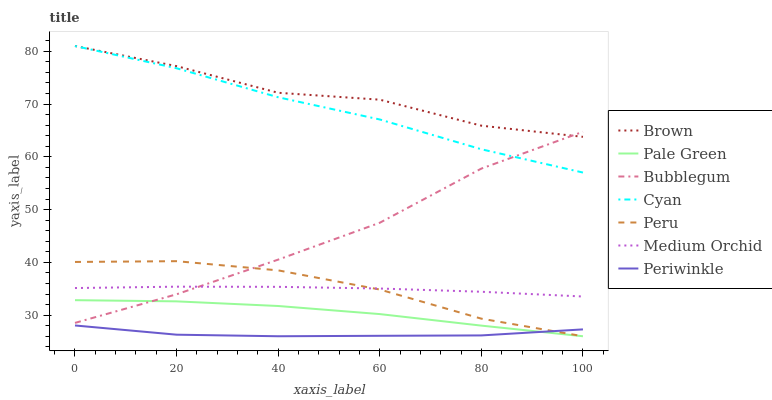Does Periwinkle have the minimum area under the curve?
Answer yes or no. Yes. Does Brown have the maximum area under the curve?
Answer yes or no. Yes. Does Medium Orchid have the minimum area under the curve?
Answer yes or no. No. Does Medium Orchid have the maximum area under the curve?
Answer yes or no. No. Is Medium Orchid the smoothest?
Answer yes or no. Yes. Is Brown the roughest?
Answer yes or no. Yes. Is Bubblegum the smoothest?
Answer yes or no. No. Is Bubblegum the roughest?
Answer yes or no. No. Does Pale Green have the lowest value?
Answer yes or no. Yes. Does Medium Orchid have the lowest value?
Answer yes or no. No. Does Cyan have the highest value?
Answer yes or no. Yes. Does Medium Orchid have the highest value?
Answer yes or no. No. Is Periwinkle less than Medium Orchid?
Answer yes or no. Yes. Is Brown greater than Peru?
Answer yes or no. Yes. Does Brown intersect Bubblegum?
Answer yes or no. Yes. Is Brown less than Bubblegum?
Answer yes or no. No. Is Brown greater than Bubblegum?
Answer yes or no. No. Does Periwinkle intersect Medium Orchid?
Answer yes or no. No. 